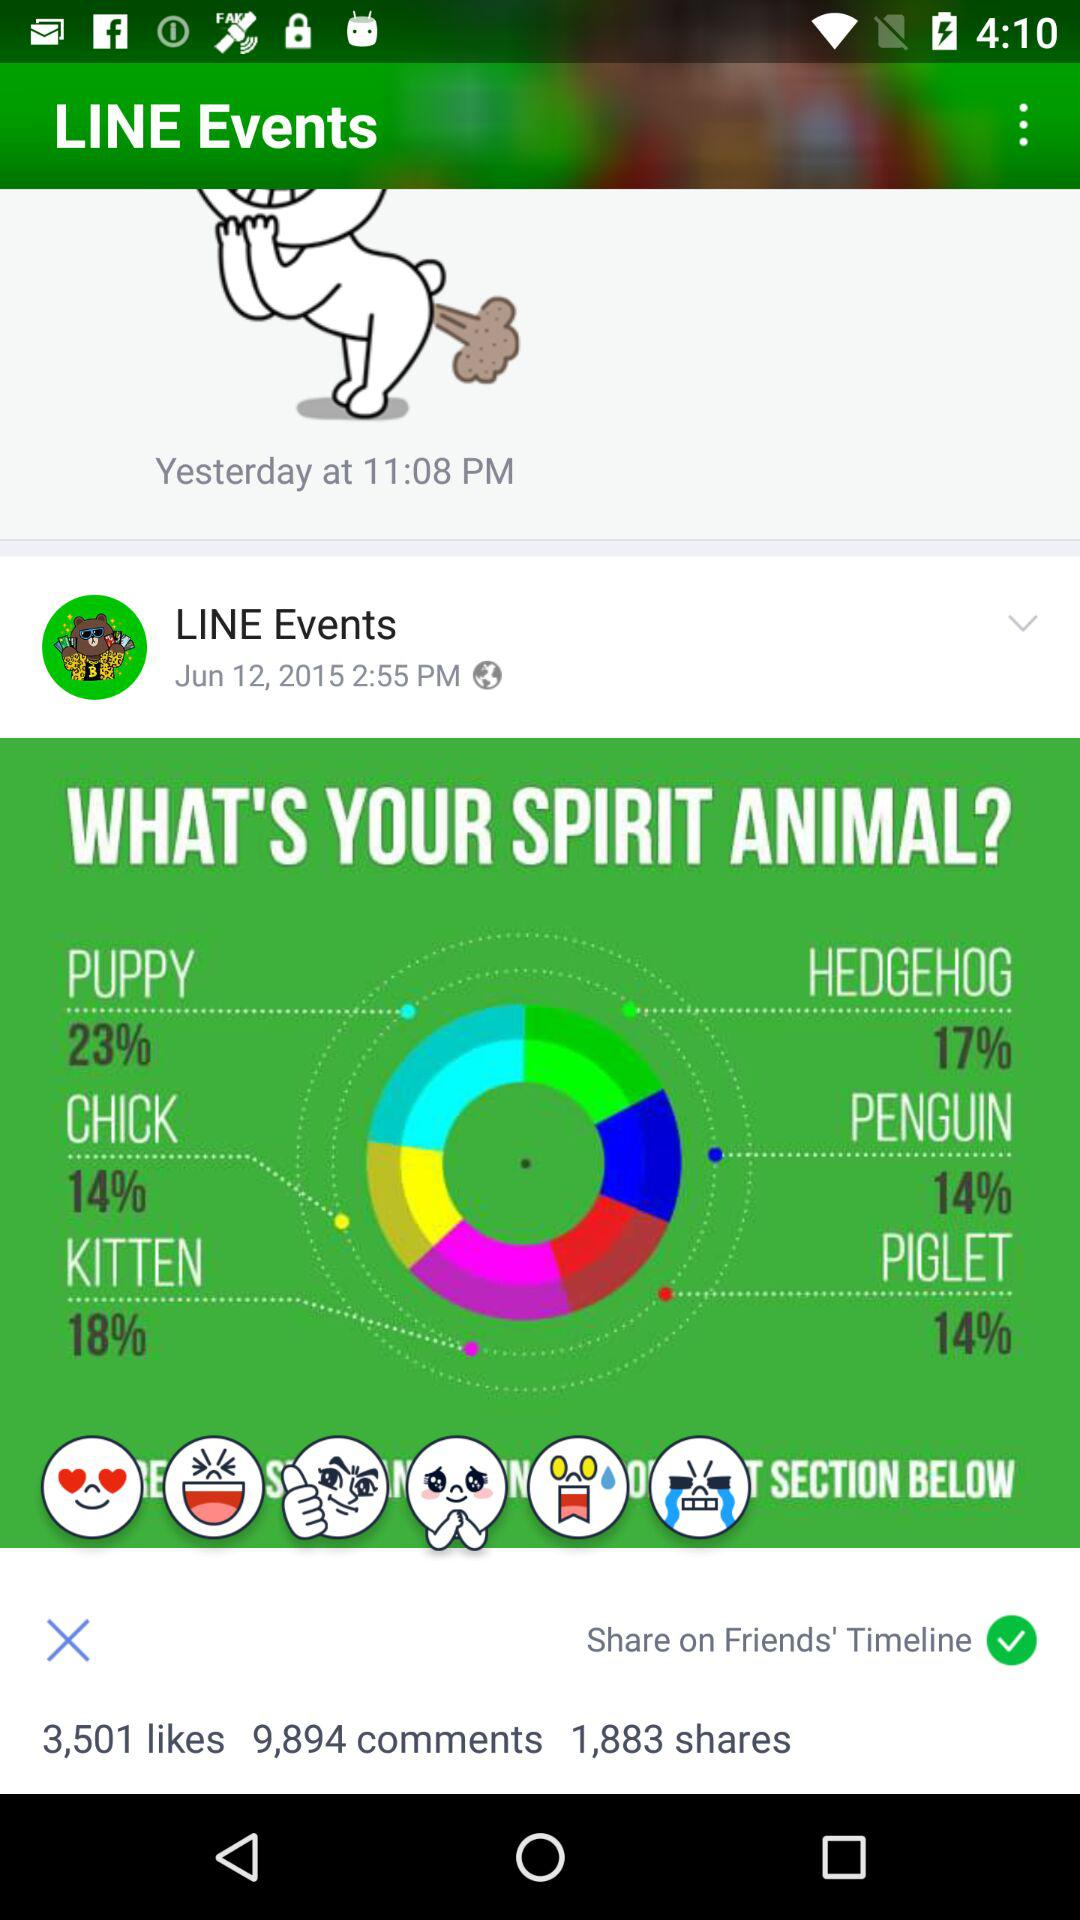On what date was the post posted by Line Events? The post was posted on June 12, 2015. 